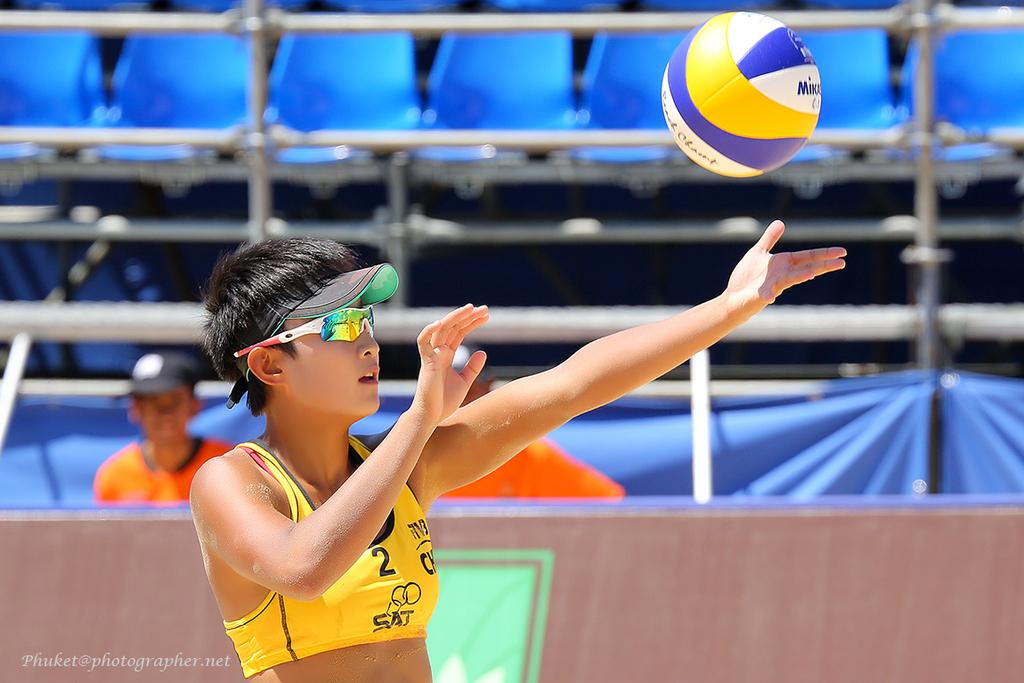<image>
Render a clear and concise summary of the photo. A woman wearing a shirts that says 2 on the front. 